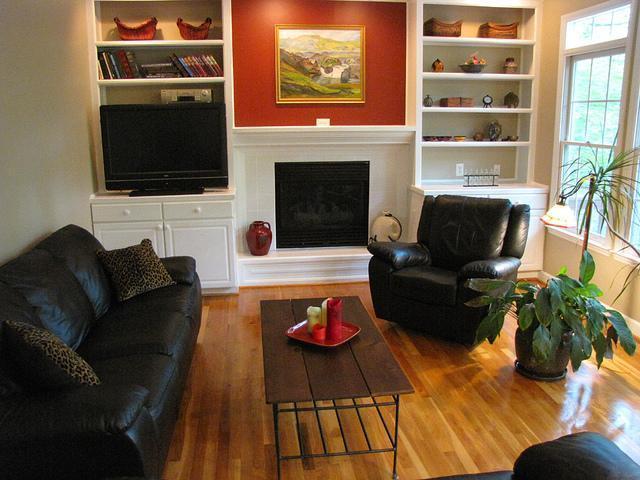How many couches are visible?
Give a very brief answer. 4. How many people holding umbrellas are in the picture?
Give a very brief answer. 0. 